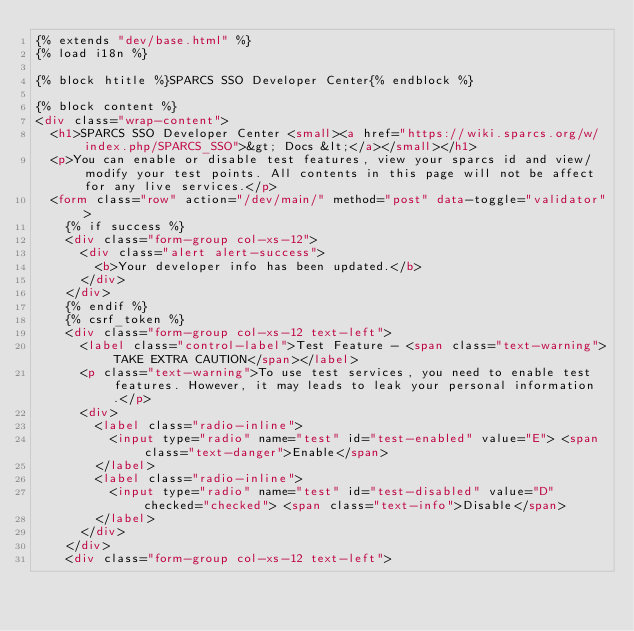<code> <loc_0><loc_0><loc_500><loc_500><_HTML_>{% extends "dev/base.html" %}
{% load i18n %}

{% block htitle %}SPARCS SSO Developer Center{% endblock %}

{% block content %}
<div class="wrap-content">
  <h1>SPARCS SSO Developer Center <small><a href="https://wiki.sparcs.org/w/index.php/SPARCS_SSO">&gt; Docs &lt;</a></small></h1>
  <p>You can enable or disable test features, view your sparcs id and view/modify your test points. All contents in this page will not be affect for any live services.</p>
  <form class="row" action="/dev/main/" method="post" data-toggle="validator">
    {% if success %}
    <div class="form-group col-xs-12">
      <div class="alert alert-success">
        <b>Your developer info has been updated.</b>
      </div>
    </div>
    {% endif %}
    {% csrf_token %}
    <div class="form-group col-xs-12 text-left">
      <label class="control-label">Test Feature - <span class="text-warning">TAKE EXTRA CAUTION</span></label>
      <p class="text-warning">To use test services, you need to enable test features. However, it may leads to leak your personal information.</p>
      <div>
        <label class="radio-inline">
          <input type="radio" name="test" id="test-enabled" value="E"> <span class="text-danger">Enable</span>
        </label>
        <label class="radio-inline">
          <input type="radio" name="test" id="test-disabled" value="D" checked="checked"> <span class="text-info">Disable</span>
        </label>
      </div>
    </div>
    <div class="form-group col-xs-12 text-left"></code> 